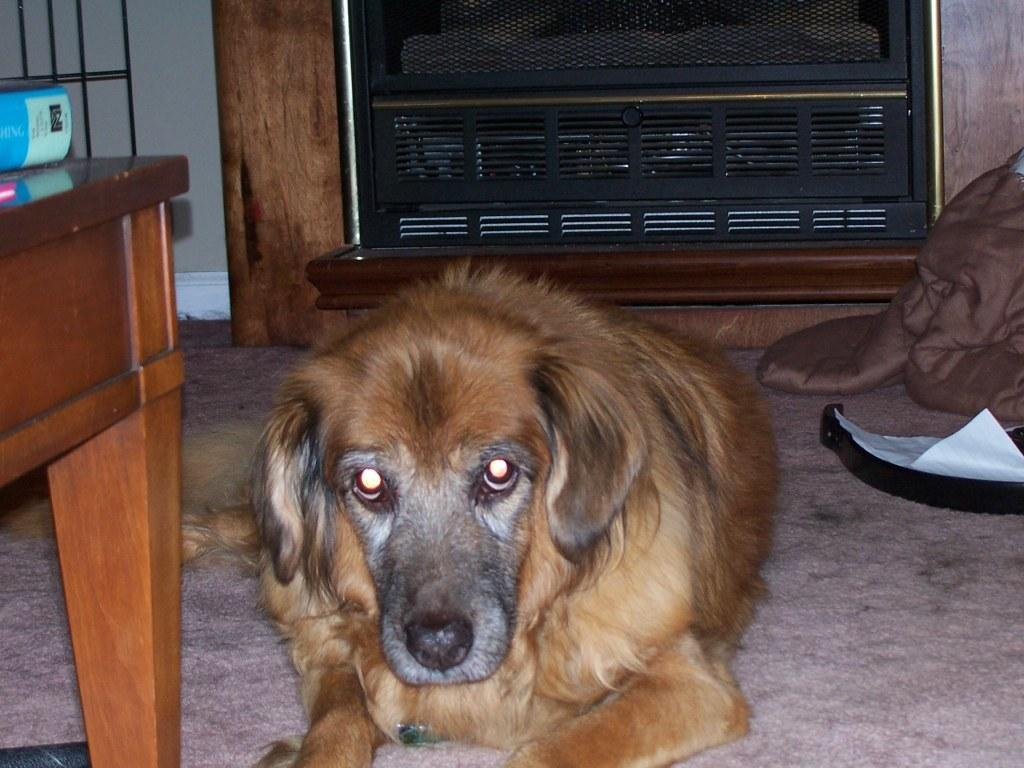What type of animal is in the image? There is a brown dog in the image. What is the dog doing in the image? The dog is sitting on the floor. What else can be seen in the image besides the dog? There is a blanket in the image. What is located on the left side of the image? There is a table on the left side of the image. What is the background of the image? There is a wall in the image. How many women are on vacation with the dog in the image? There are no women or references to vacation in the image; it only features a brown dog sitting on the floor. 